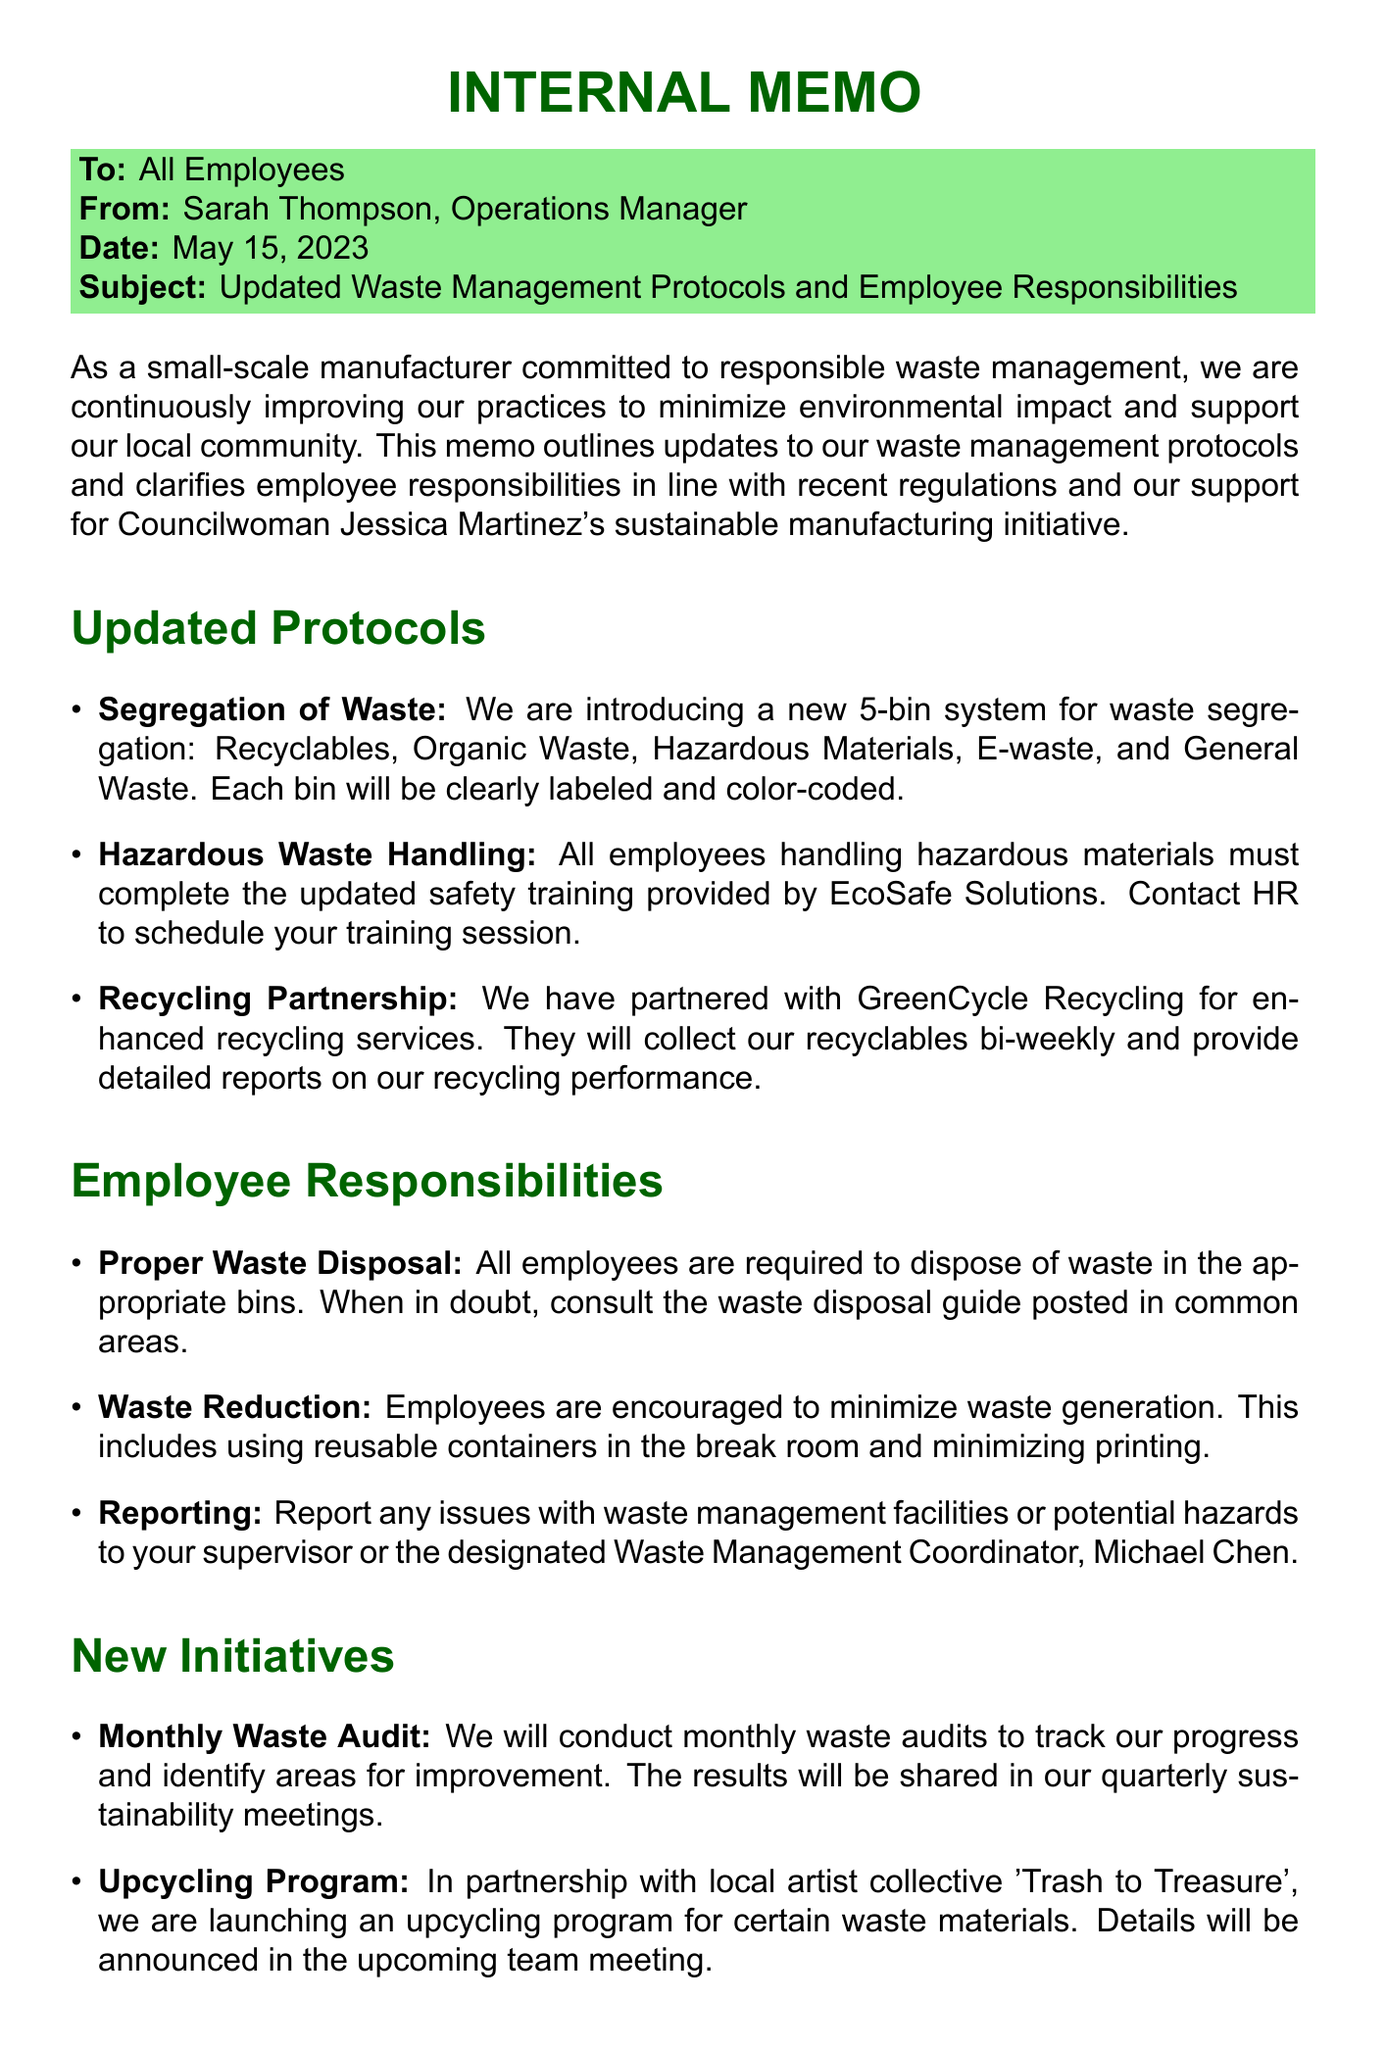what is the date of the memo? The date of the memo is specified in the memo header section.
Answer: May 15, 2023 who is the sender of the memo? The sender of the memo is mentioned in the memo header section.
Answer: Sarah Thompson, Operations Manager what is the purpose of this memo? The purpose of the memo is stated in the introduction section.
Answer: Outlines updates to waste management protocols and clarifies employee responsibilities how many types of waste are employees required to segregate? The number of waste types is specified in the updated protocols section.
Answer: 5 who is the Waste Management Coordinator? The name of the Waste Management Coordinator is mentioned in the employee responsibilities section.
Answer: Michael Chen what is the new recycling partnership mentioned? The name of the company partnered for recycling services is given in the updated protocols.
Answer: GreenCycle Recycling how often will the waste audits be conducted? The frequency of the audits is stated in the new initiatives section.
Answer: Monthly what ordinance do these updates comply with? The ordinance the updates ensure compliance with is mentioned in the compliance and support section.
Answer: City Ordinance 2023-14 what is the name of the upcycling program partner? The partner organization for the upcycling program is detailed in the new initiatives section.
Answer: Trash to Treasure 